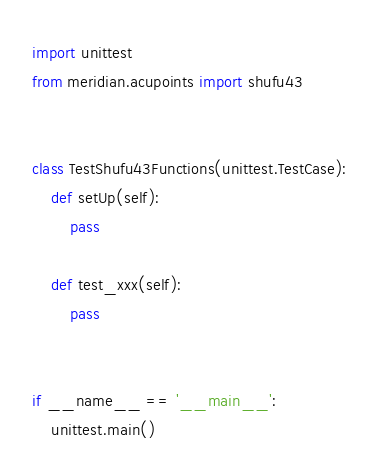Convert code to text. <code><loc_0><loc_0><loc_500><loc_500><_Python_>import unittest
from meridian.acupoints import shufu43


class TestShufu43Functions(unittest.TestCase):
    def setUp(self):
        pass

    def test_xxx(self):
        pass


if __name__ == '__main__':
    unittest.main()
</code> 